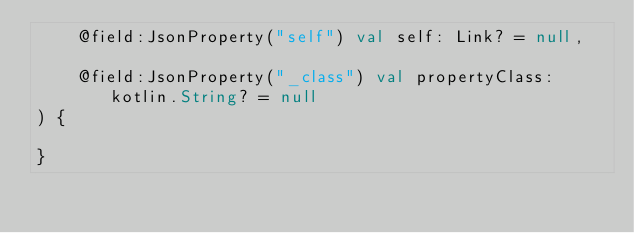Convert code to text. <code><loc_0><loc_0><loc_500><loc_500><_Kotlin_>    @field:JsonProperty("self") val self: Link? = null,

    @field:JsonProperty("_class") val propertyClass: kotlin.String? = null
) {

}

</code> 